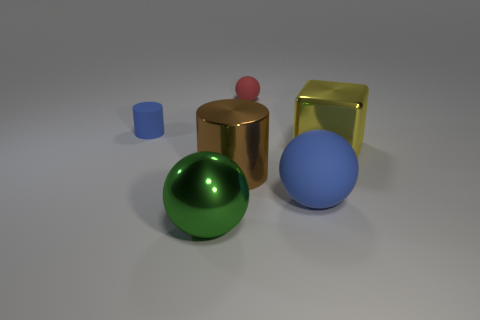Add 3 brown metal cubes. How many objects exist? 9 Subtract all blocks. How many objects are left? 5 Subtract all brown shiny things. Subtract all large green shiny things. How many objects are left? 4 Add 2 yellow metal cubes. How many yellow metal cubes are left? 3 Add 3 big cyan metal objects. How many big cyan metal objects exist? 3 Subtract 0 gray spheres. How many objects are left? 6 